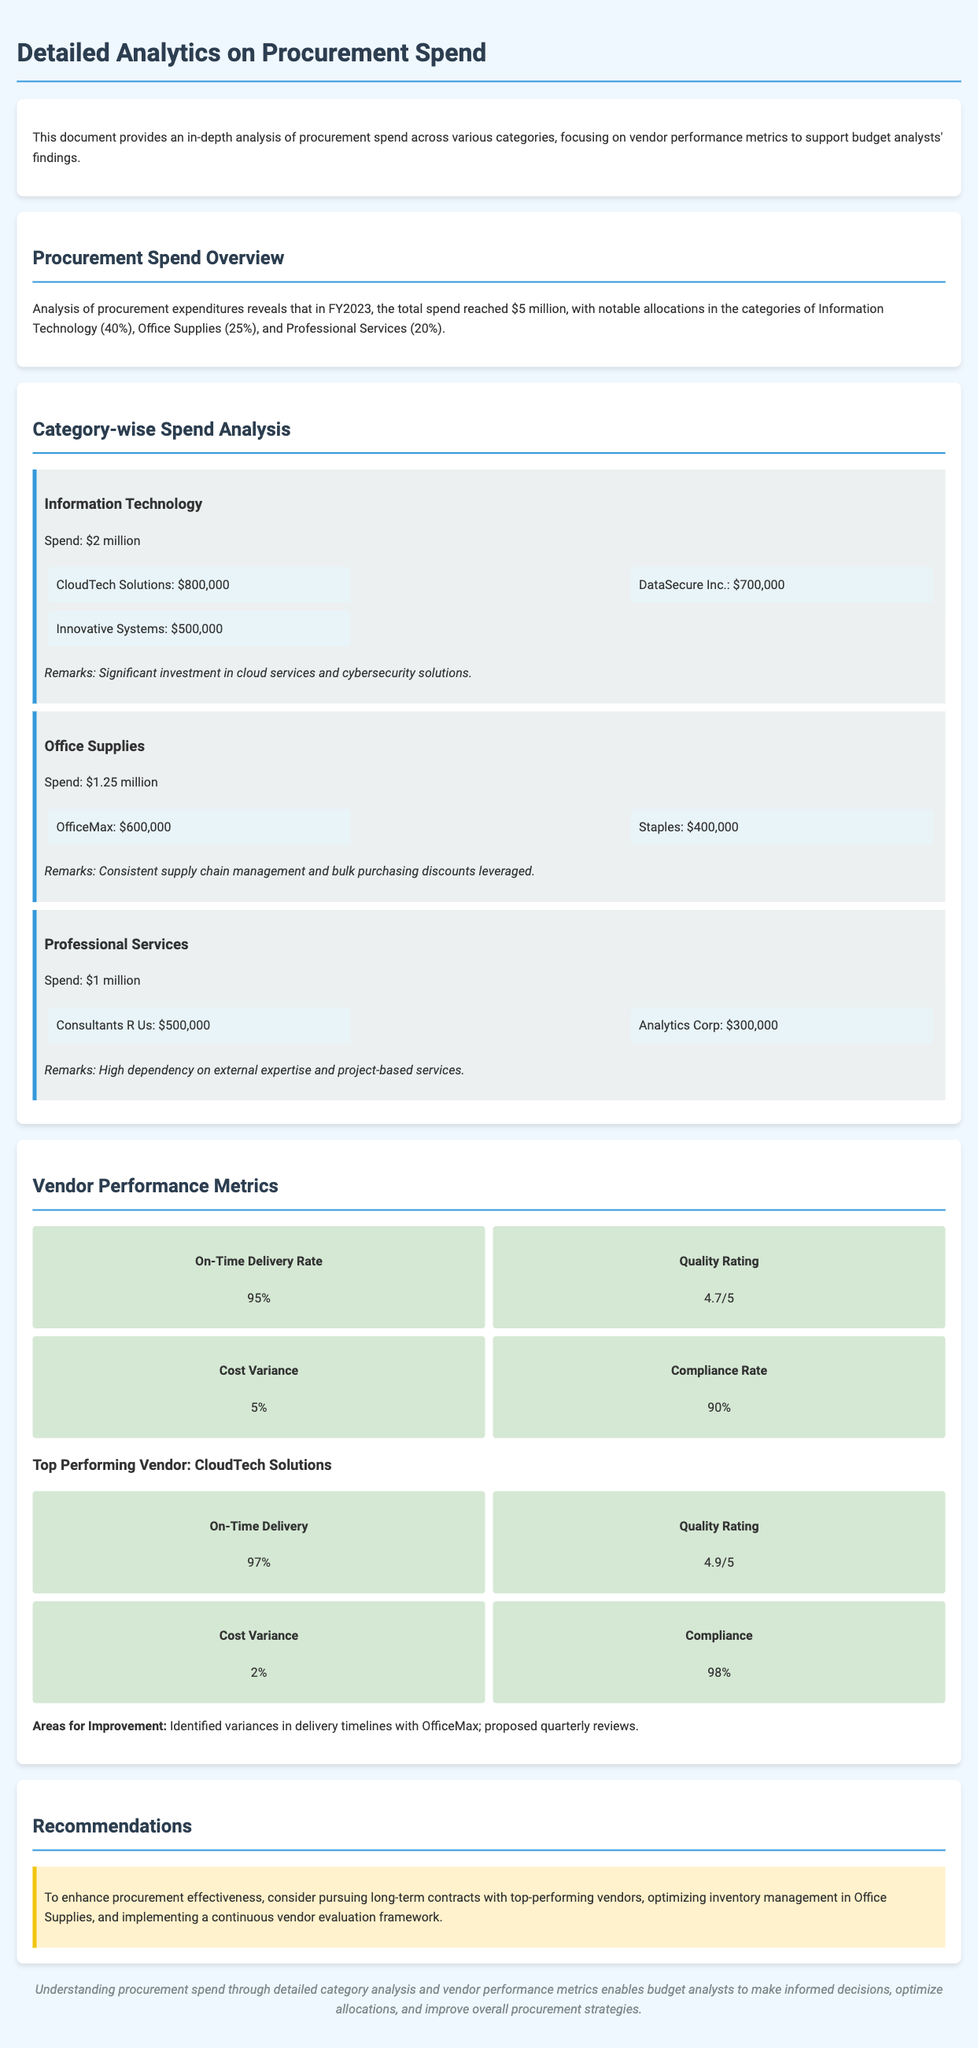What was the total procurement spend in FY2023? The total procurement spend is stated in the document as $5 million.
Answer: $5 million What percentage of the total spend was allocated to Information Technology? The document specifies that 40% of the total spend was allocated to Information Technology.
Answer: 40% Who is the top-performing vendor mentioned? The document identifies CloudTech Solutions as the top-performing vendor based on performance metrics.
Answer: CloudTech Solutions What is the cost variance percentage reported for vendor performance? Cost variance percentage is listed in the metrics section as 5%.
Answer: 5% What was the spend amount for Office Supplies? The document states that the spend amount for Office Supplies was $1.25 million.
Answer: $1.25 million What is the on-time delivery rate of the vendors? The document reports the on-time delivery rate as 95%.
Answer: 95% What remark is made about the Information Technology category? The document remarks on the significant investment in cloud services and cybersecurity solutions in the Information Technology category.
Answer: Significant investment in cloud services and cybersecurity solutions What recommendation is suggested for procurement effectiveness? The document recommends pursuing long-term contracts with top-performing vendors for enhanced procurement effectiveness.
Answer: Pursuing long-term contracts with top-performing vendors 